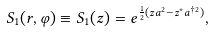<formula> <loc_0><loc_0><loc_500><loc_500>S _ { 1 } ( r , \varphi ) \equiv S _ { 1 } ( z ) = e ^ { \frac { 1 } { 2 } ( z a ^ { 2 } - z ^ { * } a ^ { \dagger 2 } ) } ,</formula> 